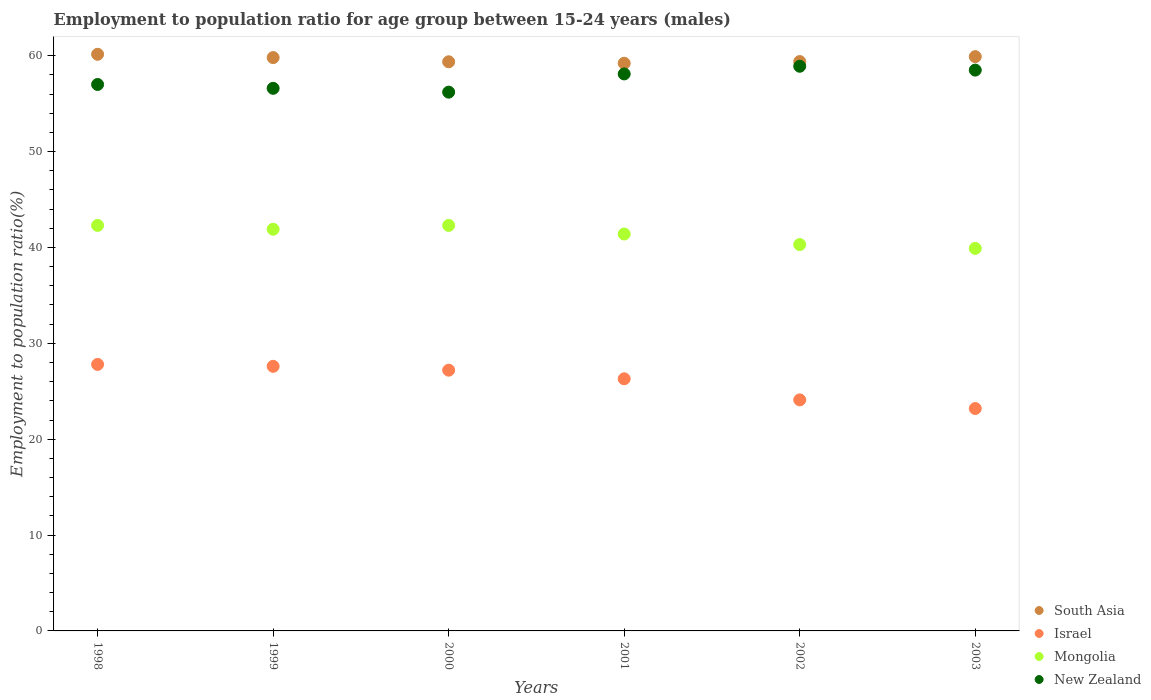How many different coloured dotlines are there?
Provide a succinct answer. 4. Is the number of dotlines equal to the number of legend labels?
Ensure brevity in your answer.  Yes. What is the employment to population ratio in New Zealand in 2003?
Ensure brevity in your answer.  58.5. Across all years, what is the maximum employment to population ratio in New Zealand?
Give a very brief answer. 58.9. Across all years, what is the minimum employment to population ratio in New Zealand?
Provide a short and direct response. 56.2. In which year was the employment to population ratio in Mongolia maximum?
Ensure brevity in your answer.  1998. What is the total employment to population ratio in South Asia in the graph?
Provide a succinct answer. 357.83. What is the difference between the employment to population ratio in South Asia in 2000 and that in 2002?
Make the answer very short. -0.02. What is the difference between the employment to population ratio in Israel in 2003 and the employment to population ratio in South Asia in 2001?
Your answer should be very brief. -36.01. What is the average employment to population ratio in Mongolia per year?
Your answer should be very brief. 41.35. In the year 2002, what is the difference between the employment to population ratio in Israel and employment to population ratio in New Zealand?
Ensure brevity in your answer.  -34.8. In how many years, is the employment to population ratio in South Asia greater than 36 %?
Your response must be concise. 6. What is the ratio of the employment to population ratio in Israel in 1998 to that in 2003?
Give a very brief answer. 1.2. What is the difference between the highest and the second highest employment to population ratio in South Asia?
Your response must be concise. 0.25. What is the difference between the highest and the lowest employment to population ratio in Mongolia?
Make the answer very short. 2.4. Is the sum of the employment to population ratio in South Asia in 2000 and 2002 greater than the maximum employment to population ratio in Israel across all years?
Your response must be concise. Yes. Is it the case that in every year, the sum of the employment to population ratio in New Zealand and employment to population ratio in Israel  is greater than the sum of employment to population ratio in Mongolia and employment to population ratio in South Asia?
Your answer should be compact. No. Does the employment to population ratio in Israel monotonically increase over the years?
Give a very brief answer. No. How many years are there in the graph?
Provide a short and direct response. 6. Are the values on the major ticks of Y-axis written in scientific E-notation?
Ensure brevity in your answer.  No. Does the graph contain grids?
Give a very brief answer. No. Where does the legend appear in the graph?
Your answer should be compact. Bottom right. What is the title of the graph?
Provide a short and direct response. Employment to population ratio for age group between 15-24 years (males). Does "Vanuatu" appear as one of the legend labels in the graph?
Ensure brevity in your answer.  No. What is the Employment to population ratio(%) of South Asia in 1998?
Offer a terse response. 60.15. What is the Employment to population ratio(%) in Israel in 1998?
Your response must be concise. 27.8. What is the Employment to population ratio(%) of Mongolia in 1998?
Make the answer very short. 42.3. What is the Employment to population ratio(%) of New Zealand in 1998?
Keep it short and to the point. 57. What is the Employment to population ratio(%) in South Asia in 1999?
Keep it short and to the point. 59.81. What is the Employment to population ratio(%) in Israel in 1999?
Your answer should be compact. 27.6. What is the Employment to population ratio(%) of Mongolia in 1999?
Provide a short and direct response. 41.9. What is the Employment to population ratio(%) of New Zealand in 1999?
Your answer should be compact. 56.6. What is the Employment to population ratio(%) in South Asia in 2000?
Your response must be concise. 59.37. What is the Employment to population ratio(%) in Israel in 2000?
Your response must be concise. 27.2. What is the Employment to population ratio(%) in Mongolia in 2000?
Provide a succinct answer. 42.3. What is the Employment to population ratio(%) of New Zealand in 2000?
Keep it short and to the point. 56.2. What is the Employment to population ratio(%) in South Asia in 2001?
Your answer should be compact. 59.21. What is the Employment to population ratio(%) of Israel in 2001?
Provide a short and direct response. 26.3. What is the Employment to population ratio(%) in Mongolia in 2001?
Offer a terse response. 41.4. What is the Employment to population ratio(%) in New Zealand in 2001?
Provide a short and direct response. 58.1. What is the Employment to population ratio(%) in South Asia in 2002?
Give a very brief answer. 59.39. What is the Employment to population ratio(%) in Israel in 2002?
Provide a succinct answer. 24.1. What is the Employment to population ratio(%) of Mongolia in 2002?
Provide a short and direct response. 40.3. What is the Employment to population ratio(%) in New Zealand in 2002?
Keep it short and to the point. 58.9. What is the Employment to population ratio(%) of South Asia in 2003?
Offer a terse response. 59.9. What is the Employment to population ratio(%) in Israel in 2003?
Offer a terse response. 23.2. What is the Employment to population ratio(%) of Mongolia in 2003?
Offer a very short reply. 39.9. What is the Employment to population ratio(%) in New Zealand in 2003?
Your response must be concise. 58.5. Across all years, what is the maximum Employment to population ratio(%) of South Asia?
Provide a short and direct response. 60.15. Across all years, what is the maximum Employment to population ratio(%) in Israel?
Ensure brevity in your answer.  27.8. Across all years, what is the maximum Employment to population ratio(%) of Mongolia?
Offer a terse response. 42.3. Across all years, what is the maximum Employment to population ratio(%) of New Zealand?
Your answer should be compact. 58.9. Across all years, what is the minimum Employment to population ratio(%) of South Asia?
Offer a very short reply. 59.21. Across all years, what is the minimum Employment to population ratio(%) of Israel?
Your answer should be very brief. 23.2. Across all years, what is the minimum Employment to population ratio(%) in Mongolia?
Ensure brevity in your answer.  39.9. Across all years, what is the minimum Employment to population ratio(%) in New Zealand?
Offer a very short reply. 56.2. What is the total Employment to population ratio(%) of South Asia in the graph?
Your response must be concise. 357.83. What is the total Employment to population ratio(%) of Israel in the graph?
Make the answer very short. 156.2. What is the total Employment to population ratio(%) of Mongolia in the graph?
Make the answer very short. 248.1. What is the total Employment to population ratio(%) in New Zealand in the graph?
Provide a short and direct response. 345.3. What is the difference between the Employment to population ratio(%) in South Asia in 1998 and that in 1999?
Your response must be concise. 0.34. What is the difference between the Employment to population ratio(%) in New Zealand in 1998 and that in 1999?
Keep it short and to the point. 0.4. What is the difference between the Employment to population ratio(%) of South Asia in 1998 and that in 2000?
Make the answer very short. 0.78. What is the difference between the Employment to population ratio(%) of Israel in 1998 and that in 2000?
Provide a succinct answer. 0.6. What is the difference between the Employment to population ratio(%) of Mongolia in 1998 and that in 2000?
Ensure brevity in your answer.  0. What is the difference between the Employment to population ratio(%) of New Zealand in 1998 and that in 2000?
Your response must be concise. 0.8. What is the difference between the Employment to population ratio(%) of South Asia in 1998 and that in 2001?
Your answer should be compact. 0.94. What is the difference between the Employment to population ratio(%) of Israel in 1998 and that in 2001?
Make the answer very short. 1.5. What is the difference between the Employment to population ratio(%) in New Zealand in 1998 and that in 2001?
Provide a short and direct response. -1.1. What is the difference between the Employment to population ratio(%) of South Asia in 1998 and that in 2002?
Your response must be concise. 0.76. What is the difference between the Employment to population ratio(%) of Israel in 1998 and that in 2002?
Keep it short and to the point. 3.7. What is the difference between the Employment to population ratio(%) of South Asia in 1998 and that in 2003?
Offer a terse response. 0.25. What is the difference between the Employment to population ratio(%) of Israel in 1998 and that in 2003?
Your response must be concise. 4.6. What is the difference between the Employment to population ratio(%) of New Zealand in 1998 and that in 2003?
Provide a short and direct response. -1.5. What is the difference between the Employment to population ratio(%) in South Asia in 1999 and that in 2000?
Your response must be concise. 0.44. What is the difference between the Employment to population ratio(%) of Mongolia in 1999 and that in 2000?
Your answer should be compact. -0.4. What is the difference between the Employment to population ratio(%) in New Zealand in 1999 and that in 2000?
Your answer should be very brief. 0.4. What is the difference between the Employment to population ratio(%) of South Asia in 1999 and that in 2001?
Provide a succinct answer. 0.59. What is the difference between the Employment to population ratio(%) in Mongolia in 1999 and that in 2001?
Keep it short and to the point. 0.5. What is the difference between the Employment to population ratio(%) of South Asia in 1999 and that in 2002?
Provide a succinct answer. 0.42. What is the difference between the Employment to population ratio(%) of Mongolia in 1999 and that in 2002?
Your response must be concise. 1.6. What is the difference between the Employment to population ratio(%) of New Zealand in 1999 and that in 2002?
Ensure brevity in your answer.  -2.3. What is the difference between the Employment to population ratio(%) of South Asia in 1999 and that in 2003?
Your answer should be very brief. -0.1. What is the difference between the Employment to population ratio(%) in New Zealand in 1999 and that in 2003?
Your response must be concise. -1.9. What is the difference between the Employment to population ratio(%) of South Asia in 2000 and that in 2001?
Your answer should be very brief. 0.15. What is the difference between the Employment to population ratio(%) in Israel in 2000 and that in 2001?
Offer a terse response. 0.9. What is the difference between the Employment to population ratio(%) in Mongolia in 2000 and that in 2001?
Ensure brevity in your answer.  0.9. What is the difference between the Employment to population ratio(%) of South Asia in 2000 and that in 2002?
Your response must be concise. -0.02. What is the difference between the Employment to population ratio(%) of Mongolia in 2000 and that in 2002?
Ensure brevity in your answer.  2. What is the difference between the Employment to population ratio(%) of New Zealand in 2000 and that in 2002?
Your response must be concise. -2.7. What is the difference between the Employment to population ratio(%) of South Asia in 2000 and that in 2003?
Your answer should be very brief. -0.54. What is the difference between the Employment to population ratio(%) of Israel in 2000 and that in 2003?
Your answer should be compact. 4. What is the difference between the Employment to population ratio(%) of Mongolia in 2000 and that in 2003?
Your answer should be very brief. 2.4. What is the difference between the Employment to population ratio(%) of South Asia in 2001 and that in 2002?
Offer a very short reply. -0.18. What is the difference between the Employment to population ratio(%) of Israel in 2001 and that in 2002?
Ensure brevity in your answer.  2.2. What is the difference between the Employment to population ratio(%) in New Zealand in 2001 and that in 2002?
Offer a terse response. -0.8. What is the difference between the Employment to population ratio(%) in South Asia in 2001 and that in 2003?
Your answer should be compact. -0.69. What is the difference between the Employment to population ratio(%) of Israel in 2001 and that in 2003?
Offer a very short reply. 3.1. What is the difference between the Employment to population ratio(%) in South Asia in 2002 and that in 2003?
Your answer should be compact. -0.51. What is the difference between the Employment to population ratio(%) of Mongolia in 2002 and that in 2003?
Offer a terse response. 0.4. What is the difference between the Employment to population ratio(%) of New Zealand in 2002 and that in 2003?
Make the answer very short. 0.4. What is the difference between the Employment to population ratio(%) in South Asia in 1998 and the Employment to population ratio(%) in Israel in 1999?
Your answer should be compact. 32.55. What is the difference between the Employment to population ratio(%) of South Asia in 1998 and the Employment to population ratio(%) of Mongolia in 1999?
Ensure brevity in your answer.  18.25. What is the difference between the Employment to population ratio(%) of South Asia in 1998 and the Employment to population ratio(%) of New Zealand in 1999?
Keep it short and to the point. 3.55. What is the difference between the Employment to population ratio(%) of Israel in 1998 and the Employment to population ratio(%) of Mongolia in 1999?
Provide a succinct answer. -14.1. What is the difference between the Employment to population ratio(%) of Israel in 1998 and the Employment to population ratio(%) of New Zealand in 1999?
Your answer should be compact. -28.8. What is the difference between the Employment to population ratio(%) in Mongolia in 1998 and the Employment to population ratio(%) in New Zealand in 1999?
Your answer should be very brief. -14.3. What is the difference between the Employment to population ratio(%) in South Asia in 1998 and the Employment to population ratio(%) in Israel in 2000?
Keep it short and to the point. 32.95. What is the difference between the Employment to population ratio(%) in South Asia in 1998 and the Employment to population ratio(%) in Mongolia in 2000?
Your response must be concise. 17.85. What is the difference between the Employment to population ratio(%) of South Asia in 1998 and the Employment to population ratio(%) of New Zealand in 2000?
Make the answer very short. 3.95. What is the difference between the Employment to population ratio(%) in Israel in 1998 and the Employment to population ratio(%) in New Zealand in 2000?
Provide a short and direct response. -28.4. What is the difference between the Employment to population ratio(%) in Mongolia in 1998 and the Employment to population ratio(%) in New Zealand in 2000?
Offer a terse response. -13.9. What is the difference between the Employment to population ratio(%) of South Asia in 1998 and the Employment to population ratio(%) of Israel in 2001?
Make the answer very short. 33.85. What is the difference between the Employment to population ratio(%) of South Asia in 1998 and the Employment to population ratio(%) of Mongolia in 2001?
Your response must be concise. 18.75. What is the difference between the Employment to population ratio(%) in South Asia in 1998 and the Employment to population ratio(%) in New Zealand in 2001?
Offer a very short reply. 2.05. What is the difference between the Employment to population ratio(%) in Israel in 1998 and the Employment to population ratio(%) in New Zealand in 2001?
Your answer should be compact. -30.3. What is the difference between the Employment to population ratio(%) in Mongolia in 1998 and the Employment to population ratio(%) in New Zealand in 2001?
Make the answer very short. -15.8. What is the difference between the Employment to population ratio(%) of South Asia in 1998 and the Employment to population ratio(%) of Israel in 2002?
Keep it short and to the point. 36.05. What is the difference between the Employment to population ratio(%) of South Asia in 1998 and the Employment to population ratio(%) of Mongolia in 2002?
Provide a succinct answer. 19.85. What is the difference between the Employment to population ratio(%) of South Asia in 1998 and the Employment to population ratio(%) of New Zealand in 2002?
Provide a short and direct response. 1.25. What is the difference between the Employment to population ratio(%) in Israel in 1998 and the Employment to population ratio(%) in New Zealand in 2002?
Your response must be concise. -31.1. What is the difference between the Employment to population ratio(%) of Mongolia in 1998 and the Employment to population ratio(%) of New Zealand in 2002?
Make the answer very short. -16.6. What is the difference between the Employment to population ratio(%) in South Asia in 1998 and the Employment to population ratio(%) in Israel in 2003?
Give a very brief answer. 36.95. What is the difference between the Employment to population ratio(%) in South Asia in 1998 and the Employment to population ratio(%) in Mongolia in 2003?
Provide a short and direct response. 20.25. What is the difference between the Employment to population ratio(%) in South Asia in 1998 and the Employment to population ratio(%) in New Zealand in 2003?
Your response must be concise. 1.65. What is the difference between the Employment to population ratio(%) of Israel in 1998 and the Employment to population ratio(%) of Mongolia in 2003?
Your response must be concise. -12.1. What is the difference between the Employment to population ratio(%) of Israel in 1998 and the Employment to population ratio(%) of New Zealand in 2003?
Your answer should be compact. -30.7. What is the difference between the Employment to population ratio(%) of Mongolia in 1998 and the Employment to population ratio(%) of New Zealand in 2003?
Provide a short and direct response. -16.2. What is the difference between the Employment to population ratio(%) in South Asia in 1999 and the Employment to population ratio(%) in Israel in 2000?
Make the answer very short. 32.61. What is the difference between the Employment to population ratio(%) of South Asia in 1999 and the Employment to population ratio(%) of Mongolia in 2000?
Give a very brief answer. 17.51. What is the difference between the Employment to population ratio(%) of South Asia in 1999 and the Employment to population ratio(%) of New Zealand in 2000?
Offer a terse response. 3.61. What is the difference between the Employment to population ratio(%) in Israel in 1999 and the Employment to population ratio(%) in Mongolia in 2000?
Offer a terse response. -14.7. What is the difference between the Employment to population ratio(%) of Israel in 1999 and the Employment to population ratio(%) of New Zealand in 2000?
Your response must be concise. -28.6. What is the difference between the Employment to population ratio(%) in Mongolia in 1999 and the Employment to population ratio(%) in New Zealand in 2000?
Provide a succinct answer. -14.3. What is the difference between the Employment to population ratio(%) in South Asia in 1999 and the Employment to population ratio(%) in Israel in 2001?
Ensure brevity in your answer.  33.51. What is the difference between the Employment to population ratio(%) in South Asia in 1999 and the Employment to population ratio(%) in Mongolia in 2001?
Your answer should be compact. 18.41. What is the difference between the Employment to population ratio(%) in South Asia in 1999 and the Employment to population ratio(%) in New Zealand in 2001?
Offer a terse response. 1.71. What is the difference between the Employment to population ratio(%) of Israel in 1999 and the Employment to population ratio(%) of New Zealand in 2001?
Give a very brief answer. -30.5. What is the difference between the Employment to population ratio(%) in Mongolia in 1999 and the Employment to population ratio(%) in New Zealand in 2001?
Ensure brevity in your answer.  -16.2. What is the difference between the Employment to population ratio(%) in South Asia in 1999 and the Employment to population ratio(%) in Israel in 2002?
Make the answer very short. 35.71. What is the difference between the Employment to population ratio(%) of South Asia in 1999 and the Employment to population ratio(%) of Mongolia in 2002?
Your response must be concise. 19.51. What is the difference between the Employment to population ratio(%) of South Asia in 1999 and the Employment to population ratio(%) of New Zealand in 2002?
Ensure brevity in your answer.  0.91. What is the difference between the Employment to population ratio(%) in Israel in 1999 and the Employment to population ratio(%) in New Zealand in 2002?
Make the answer very short. -31.3. What is the difference between the Employment to population ratio(%) of Mongolia in 1999 and the Employment to population ratio(%) of New Zealand in 2002?
Your answer should be very brief. -17. What is the difference between the Employment to population ratio(%) in South Asia in 1999 and the Employment to population ratio(%) in Israel in 2003?
Provide a short and direct response. 36.61. What is the difference between the Employment to population ratio(%) in South Asia in 1999 and the Employment to population ratio(%) in Mongolia in 2003?
Provide a short and direct response. 19.91. What is the difference between the Employment to population ratio(%) in South Asia in 1999 and the Employment to population ratio(%) in New Zealand in 2003?
Your answer should be very brief. 1.31. What is the difference between the Employment to population ratio(%) of Israel in 1999 and the Employment to population ratio(%) of Mongolia in 2003?
Your response must be concise. -12.3. What is the difference between the Employment to population ratio(%) in Israel in 1999 and the Employment to population ratio(%) in New Zealand in 2003?
Make the answer very short. -30.9. What is the difference between the Employment to population ratio(%) of Mongolia in 1999 and the Employment to population ratio(%) of New Zealand in 2003?
Offer a terse response. -16.6. What is the difference between the Employment to population ratio(%) in South Asia in 2000 and the Employment to population ratio(%) in Israel in 2001?
Your answer should be compact. 33.07. What is the difference between the Employment to population ratio(%) in South Asia in 2000 and the Employment to population ratio(%) in Mongolia in 2001?
Offer a terse response. 17.97. What is the difference between the Employment to population ratio(%) of South Asia in 2000 and the Employment to population ratio(%) of New Zealand in 2001?
Provide a succinct answer. 1.27. What is the difference between the Employment to population ratio(%) in Israel in 2000 and the Employment to population ratio(%) in Mongolia in 2001?
Keep it short and to the point. -14.2. What is the difference between the Employment to population ratio(%) of Israel in 2000 and the Employment to population ratio(%) of New Zealand in 2001?
Offer a terse response. -30.9. What is the difference between the Employment to population ratio(%) in Mongolia in 2000 and the Employment to population ratio(%) in New Zealand in 2001?
Offer a terse response. -15.8. What is the difference between the Employment to population ratio(%) of South Asia in 2000 and the Employment to population ratio(%) of Israel in 2002?
Your answer should be compact. 35.27. What is the difference between the Employment to population ratio(%) in South Asia in 2000 and the Employment to population ratio(%) in Mongolia in 2002?
Ensure brevity in your answer.  19.07. What is the difference between the Employment to population ratio(%) of South Asia in 2000 and the Employment to population ratio(%) of New Zealand in 2002?
Provide a short and direct response. 0.47. What is the difference between the Employment to population ratio(%) of Israel in 2000 and the Employment to population ratio(%) of Mongolia in 2002?
Your response must be concise. -13.1. What is the difference between the Employment to population ratio(%) in Israel in 2000 and the Employment to population ratio(%) in New Zealand in 2002?
Ensure brevity in your answer.  -31.7. What is the difference between the Employment to population ratio(%) in Mongolia in 2000 and the Employment to population ratio(%) in New Zealand in 2002?
Offer a terse response. -16.6. What is the difference between the Employment to population ratio(%) in South Asia in 2000 and the Employment to population ratio(%) in Israel in 2003?
Give a very brief answer. 36.17. What is the difference between the Employment to population ratio(%) in South Asia in 2000 and the Employment to population ratio(%) in Mongolia in 2003?
Offer a very short reply. 19.47. What is the difference between the Employment to population ratio(%) in South Asia in 2000 and the Employment to population ratio(%) in New Zealand in 2003?
Keep it short and to the point. 0.87. What is the difference between the Employment to population ratio(%) in Israel in 2000 and the Employment to population ratio(%) in New Zealand in 2003?
Your response must be concise. -31.3. What is the difference between the Employment to population ratio(%) in Mongolia in 2000 and the Employment to population ratio(%) in New Zealand in 2003?
Offer a very short reply. -16.2. What is the difference between the Employment to population ratio(%) of South Asia in 2001 and the Employment to population ratio(%) of Israel in 2002?
Give a very brief answer. 35.11. What is the difference between the Employment to population ratio(%) in South Asia in 2001 and the Employment to population ratio(%) in Mongolia in 2002?
Ensure brevity in your answer.  18.91. What is the difference between the Employment to population ratio(%) in South Asia in 2001 and the Employment to population ratio(%) in New Zealand in 2002?
Your response must be concise. 0.31. What is the difference between the Employment to population ratio(%) in Israel in 2001 and the Employment to population ratio(%) in New Zealand in 2002?
Provide a short and direct response. -32.6. What is the difference between the Employment to population ratio(%) of Mongolia in 2001 and the Employment to population ratio(%) of New Zealand in 2002?
Offer a terse response. -17.5. What is the difference between the Employment to population ratio(%) in South Asia in 2001 and the Employment to population ratio(%) in Israel in 2003?
Offer a terse response. 36.01. What is the difference between the Employment to population ratio(%) of South Asia in 2001 and the Employment to population ratio(%) of Mongolia in 2003?
Keep it short and to the point. 19.31. What is the difference between the Employment to population ratio(%) in South Asia in 2001 and the Employment to population ratio(%) in New Zealand in 2003?
Keep it short and to the point. 0.71. What is the difference between the Employment to population ratio(%) in Israel in 2001 and the Employment to population ratio(%) in Mongolia in 2003?
Give a very brief answer. -13.6. What is the difference between the Employment to population ratio(%) in Israel in 2001 and the Employment to population ratio(%) in New Zealand in 2003?
Offer a terse response. -32.2. What is the difference between the Employment to population ratio(%) in Mongolia in 2001 and the Employment to population ratio(%) in New Zealand in 2003?
Provide a short and direct response. -17.1. What is the difference between the Employment to population ratio(%) in South Asia in 2002 and the Employment to population ratio(%) in Israel in 2003?
Your answer should be compact. 36.19. What is the difference between the Employment to population ratio(%) of South Asia in 2002 and the Employment to population ratio(%) of Mongolia in 2003?
Offer a very short reply. 19.49. What is the difference between the Employment to population ratio(%) in South Asia in 2002 and the Employment to population ratio(%) in New Zealand in 2003?
Your answer should be compact. 0.89. What is the difference between the Employment to population ratio(%) of Israel in 2002 and the Employment to population ratio(%) of Mongolia in 2003?
Offer a very short reply. -15.8. What is the difference between the Employment to population ratio(%) of Israel in 2002 and the Employment to population ratio(%) of New Zealand in 2003?
Keep it short and to the point. -34.4. What is the difference between the Employment to population ratio(%) in Mongolia in 2002 and the Employment to population ratio(%) in New Zealand in 2003?
Keep it short and to the point. -18.2. What is the average Employment to population ratio(%) of South Asia per year?
Ensure brevity in your answer.  59.64. What is the average Employment to population ratio(%) in Israel per year?
Provide a succinct answer. 26.03. What is the average Employment to population ratio(%) in Mongolia per year?
Ensure brevity in your answer.  41.35. What is the average Employment to population ratio(%) of New Zealand per year?
Keep it short and to the point. 57.55. In the year 1998, what is the difference between the Employment to population ratio(%) in South Asia and Employment to population ratio(%) in Israel?
Your response must be concise. 32.35. In the year 1998, what is the difference between the Employment to population ratio(%) of South Asia and Employment to population ratio(%) of Mongolia?
Ensure brevity in your answer.  17.85. In the year 1998, what is the difference between the Employment to population ratio(%) in South Asia and Employment to population ratio(%) in New Zealand?
Make the answer very short. 3.15. In the year 1998, what is the difference between the Employment to population ratio(%) of Israel and Employment to population ratio(%) of Mongolia?
Your response must be concise. -14.5. In the year 1998, what is the difference between the Employment to population ratio(%) in Israel and Employment to population ratio(%) in New Zealand?
Provide a succinct answer. -29.2. In the year 1998, what is the difference between the Employment to population ratio(%) of Mongolia and Employment to population ratio(%) of New Zealand?
Your response must be concise. -14.7. In the year 1999, what is the difference between the Employment to population ratio(%) of South Asia and Employment to population ratio(%) of Israel?
Give a very brief answer. 32.21. In the year 1999, what is the difference between the Employment to population ratio(%) in South Asia and Employment to population ratio(%) in Mongolia?
Make the answer very short. 17.91. In the year 1999, what is the difference between the Employment to population ratio(%) in South Asia and Employment to population ratio(%) in New Zealand?
Offer a very short reply. 3.21. In the year 1999, what is the difference between the Employment to population ratio(%) of Israel and Employment to population ratio(%) of Mongolia?
Ensure brevity in your answer.  -14.3. In the year 1999, what is the difference between the Employment to population ratio(%) in Israel and Employment to population ratio(%) in New Zealand?
Give a very brief answer. -29. In the year 1999, what is the difference between the Employment to population ratio(%) of Mongolia and Employment to population ratio(%) of New Zealand?
Your response must be concise. -14.7. In the year 2000, what is the difference between the Employment to population ratio(%) in South Asia and Employment to population ratio(%) in Israel?
Keep it short and to the point. 32.17. In the year 2000, what is the difference between the Employment to population ratio(%) of South Asia and Employment to population ratio(%) of Mongolia?
Your answer should be very brief. 17.07. In the year 2000, what is the difference between the Employment to population ratio(%) in South Asia and Employment to population ratio(%) in New Zealand?
Provide a succinct answer. 3.17. In the year 2000, what is the difference between the Employment to population ratio(%) in Israel and Employment to population ratio(%) in Mongolia?
Your answer should be compact. -15.1. In the year 2000, what is the difference between the Employment to population ratio(%) in Israel and Employment to population ratio(%) in New Zealand?
Provide a short and direct response. -29. In the year 2000, what is the difference between the Employment to population ratio(%) in Mongolia and Employment to population ratio(%) in New Zealand?
Offer a terse response. -13.9. In the year 2001, what is the difference between the Employment to population ratio(%) of South Asia and Employment to population ratio(%) of Israel?
Provide a short and direct response. 32.91. In the year 2001, what is the difference between the Employment to population ratio(%) of South Asia and Employment to population ratio(%) of Mongolia?
Make the answer very short. 17.81. In the year 2001, what is the difference between the Employment to population ratio(%) of South Asia and Employment to population ratio(%) of New Zealand?
Make the answer very short. 1.11. In the year 2001, what is the difference between the Employment to population ratio(%) of Israel and Employment to population ratio(%) of Mongolia?
Make the answer very short. -15.1. In the year 2001, what is the difference between the Employment to population ratio(%) of Israel and Employment to population ratio(%) of New Zealand?
Ensure brevity in your answer.  -31.8. In the year 2001, what is the difference between the Employment to population ratio(%) in Mongolia and Employment to population ratio(%) in New Zealand?
Your response must be concise. -16.7. In the year 2002, what is the difference between the Employment to population ratio(%) of South Asia and Employment to population ratio(%) of Israel?
Give a very brief answer. 35.29. In the year 2002, what is the difference between the Employment to population ratio(%) in South Asia and Employment to population ratio(%) in Mongolia?
Offer a very short reply. 19.09. In the year 2002, what is the difference between the Employment to population ratio(%) of South Asia and Employment to population ratio(%) of New Zealand?
Your response must be concise. 0.49. In the year 2002, what is the difference between the Employment to population ratio(%) of Israel and Employment to population ratio(%) of Mongolia?
Keep it short and to the point. -16.2. In the year 2002, what is the difference between the Employment to population ratio(%) in Israel and Employment to population ratio(%) in New Zealand?
Your answer should be compact. -34.8. In the year 2002, what is the difference between the Employment to population ratio(%) in Mongolia and Employment to population ratio(%) in New Zealand?
Give a very brief answer. -18.6. In the year 2003, what is the difference between the Employment to population ratio(%) of South Asia and Employment to population ratio(%) of Israel?
Your answer should be compact. 36.7. In the year 2003, what is the difference between the Employment to population ratio(%) in South Asia and Employment to population ratio(%) in Mongolia?
Keep it short and to the point. 20. In the year 2003, what is the difference between the Employment to population ratio(%) of South Asia and Employment to population ratio(%) of New Zealand?
Offer a very short reply. 1.4. In the year 2003, what is the difference between the Employment to population ratio(%) in Israel and Employment to population ratio(%) in Mongolia?
Your answer should be very brief. -16.7. In the year 2003, what is the difference between the Employment to population ratio(%) of Israel and Employment to population ratio(%) of New Zealand?
Keep it short and to the point. -35.3. In the year 2003, what is the difference between the Employment to population ratio(%) of Mongolia and Employment to population ratio(%) of New Zealand?
Your answer should be compact. -18.6. What is the ratio of the Employment to population ratio(%) in South Asia in 1998 to that in 1999?
Make the answer very short. 1.01. What is the ratio of the Employment to population ratio(%) of Mongolia in 1998 to that in 1999?
Make the answer very short. 1.01. What is the ratio of the Employment to population ratio(%) in New Zealand in 1998 to that in 1999?
Give a very brief answer. 1.01. What is the ratio of the Employment to population ratio(%) in South Asia in 1998 to that in 2000?
Provide a short and direct response. 1.01. What is the ratio of the Employment to population ratio(%) of Israel in 1998 to that in 2000?
Your answer should be compact. 1.02. What is the ratio of the Employment to population ratio(%) of Mongolia in 1998 to that in 2000?
Offer a very short reply. 1. What is the ratio of the Employment to population ratio(%) of New Zealand in 1998 to that in 2000?
Give a very brief answer. 1.01. What is the ratio of the Employment to population ratio(%) of South Asia in 1998 to that in 2001?
Make the answer very short. 1.02. What is the ratio of the Employment to population ratio(%) of Israel in 1998 to that in 2001?
Offer a terse response. 1.06. What is the ratio of the Employment to population ratio(%) of Mongolia in 1998 to that in 2001?
Ensure brevity in your answer.  1.02. What is the ratio of the Employment to population ratio(%) of New Zealand in 1998 to that in 2001?
Your answer should be very brief. 0.98. What is the ratio of the Employment to population ratio(%) of South Asia in 1998 to that in 2002?
Provide a succinct answer. 1.01. What is the ratio of the Employment to population ratio(%) in Israel in 1998 to that in 2002?
Your response must be concise. 1.15. What is the ratio of the Employment to population ratio(%) in Mongolia in 1998 to that in 2002?
Give a very brief answer. 1.05. What is the ratio of the Employment to population ratio(%) in Israel in 1998 to that in 2003?
Give a very brief answer. 1.2. What is the ratio of the Employment to population ratio(%) of Mongolia in 1998 to that in 2003?
Give a very brief answer. 1.06. What is the ratio of the Employment to population ratio(%) in New Zealand in 1998 to that in 2003?
Offer a terse response. 0.97. What is the ratio of the Employment to population ratio(%) in South Asia in 1999 to that in 2000?
Your response must be concise. 1.01. What is the ratio of the Employment to population ratio(%) of Israel in 1999 to that in 2000?
Offer a very short reply. 1.01. What is the ratio of the Employment to population ratio(%) in New Zealand in 1999 to that in 2000?
Give a very brief answer. 1.01. What is the ratio of the Employment to population ratio(%) in South Asia in 1999 to that in 2001?
Give a very brief answer. 1.01. What is the ratio of the Employment to population ratio(%) of Israel in 1999 to that in 2001?
Give a very brief answer. 1.05. What is the ratio of the Employment to population ratio(%) in Mongolia in 1999 to that in 2001?
Your response must be concise. 1.01. What is the ratio of the Employment to population ratio(%) in New Zealand in 1999 to that in 2001?
Provide a short and direct response. 0.97. What is the ratio of the Employment to population ratio(%) of Israel in 1999 to that in 2002?
Your answer should be compact. 1.15. What is the ratio of the Employment to population ratio(%) of Mongolia in 1999 to that in 2002?
Your answer should be very brief. 1.04. What is the ratio of the Employment to population ratio(%) of Israel in 1999 to that in 2003?
Your response must be concise. 1.19. What is the ratio of the Employment to population ratio(%) of Mongolia in 1999 to that in 2003?
Make the answer very short. 1.05. What is the ratio of the Employment to population ratio(%) in New Zealand in 1999 to that in 2003?
Offer a terse response. 0.97. What is the ratio of the Employment to population ratio(%) in South Asia in 2000 to that in 2001?
Make the answer very short. 1. What is the ratio of the Employment to population ratio(%) of Israel in 2000 to that in 2001?
Offer a very short reply. 1.03. What is the ratio of the Employment to population ratio(%) in Mongolia in 2000 to that in 2001?
Provide a succinct answer. 1.02. What is the ratio of the Employment to population ratio(%) of New Zealand in 2000 to that in 2001?
Ensure brevity in your answer.  0.97. What is the ratio of the Employment to population ratio(%) in Israel in 2000 to that in 2002?
Your response must be concise. 1.13. What is the ratio of the Employment to population ratio(%) in Mongolia in 2000 to that in 2002?
Your answer should be compact. 1.05. What is the ratio of the Employment to population ratio(%) in New Zealand in 2000 to that in 2002?
Ensure brevity in your answer.  0.95. What is the ratio of the Employment to population ratio(%) in Israel in 2000 to that in 2003?
Offer a terse response. 1.17. What is the ratio of the Employment to population ratio(%) in Mongolia in 2000 to that in 2003?
Your answer should be compact. 1.06. What is the ratio of the Employment to population ratio(%) in New Zealand in 2000 to that in 2003?
Provide a succinct answer. 0.96. What is the ratio of the Employment to population ratio(%) of Israel in 2001 to that in 2002?
Your answer should be compact. 1.09. What is the ratio of the Employment to population ratio(%) in Mongolia in 2001 to that in 2002?
Give a very brief answer. 1.03. What is the ratio of the Employment to population ratio(%) of New Zealand in 2001 to that in 2002?
Offer a terse response. 0.99. What is the ratio of the Employment to population ratio(%) of Israel in 2001 to that in 2003?
Make the answer very short. 1.13. What is the ratio of the Employment to population ratio(%) of Mongolia in 2001 to that in 2003?
Your answer should be compact. 1.04. What is the ratio of the Employment to population ratio(%) in New Zealand in 2001 to that in 2003?
Your answer should be compact. 0.99. What is the ratio of the Employment to population ratio(%) of South Asia in 2002 to that in 2003?
Keep it short and to the point. 0.99. What is the ratio of the Employment to population ratio(%) in Israel in 2002 to that in 2003?
Make the answer very short. 1.04. What is the ratio of the Employment to population ratio(%) of New Zealand in 2002 to that in 2003?
Your answer should be compact. 1.01. What is the difference between the highest and the second highest Employment to population ratio(%) of South Asia?
Your response must be concise. 0.25. What is the difference between the highest and the second highest Employment to population ratio(%) in Israel?
Make the answer very short. 0.2. What is the difference between the highest and the lowest Employment to population ratio(%) of South Asia?
Provide a short and direct response. 0.94. What is the difference between the highest and the lowest Employment to population ratio(%) in Israel?
Ensure brevity in your answer.  4.6. What is the difference between the highest and the lowest Employment to population ratio(%) in Mongolia?
Provide a succinct answer. 2.4. 